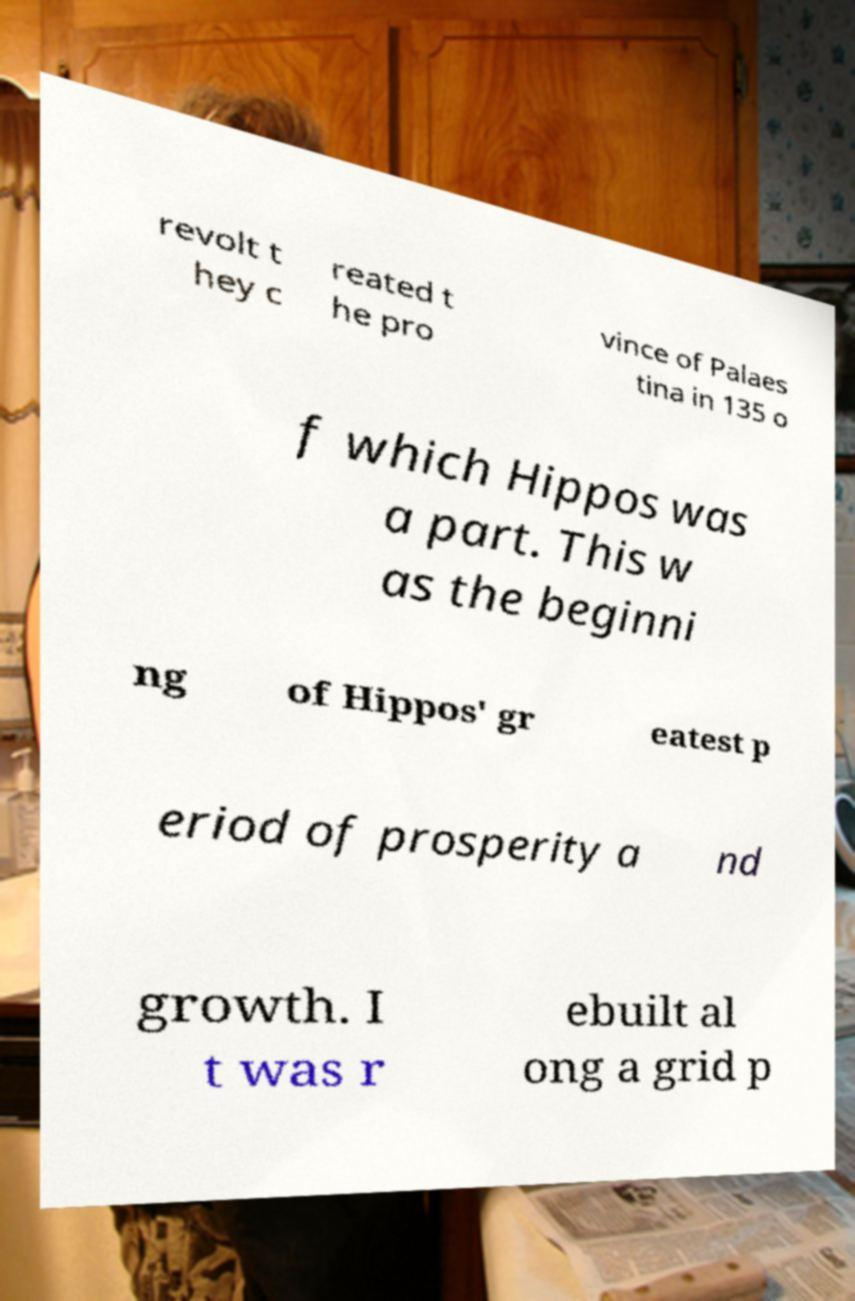Could you extract and type out the text from this image? revolt t hey c reated t he pro vince of Palaes tina in 135 o f which Hippos was a part. This w as the beginni ng of Hippos' gr eatest p eriod of prosperity a nd growth. I t was r ebuilt al ong a grid p 